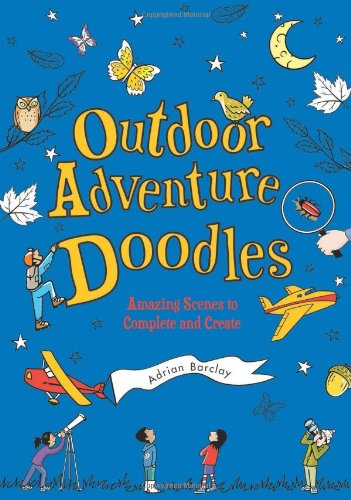Who wrote this book?
Answer the question using a single word or phrase. Adrian Barclay What is the title of this book? Outdoor Adventure Doodles: Amazing Scenes to Complete and Create What type of book is this? Children's Books Is this a kids book? Yes Is this christianity book? No 